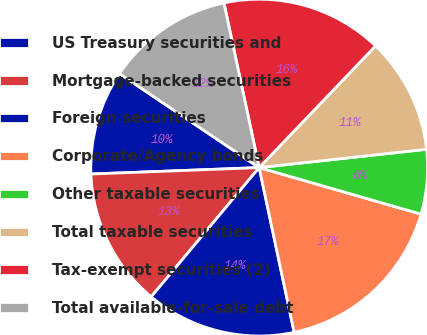<chart> <loc_0><loc_0><loc_500><loc_500><pie_chart><fcel>US Treasury securities and<fcel>Mortgage-backed securities<fcel>Foreign securities<fcel>Corporate/Agency bonds<fcel>Other taxable securities<fcel>Total taxable securities<fcel>Tax-exempt securities (2)<fcel>Total available-for-sale debt<nl><fcel>10.03%<fcel>13.31%<fcel>14.41%<fcel>17.21%<fcel>6.19%<fcel>11.12%<fcel>15.5%<fcel>12.22%<nl></chart> 